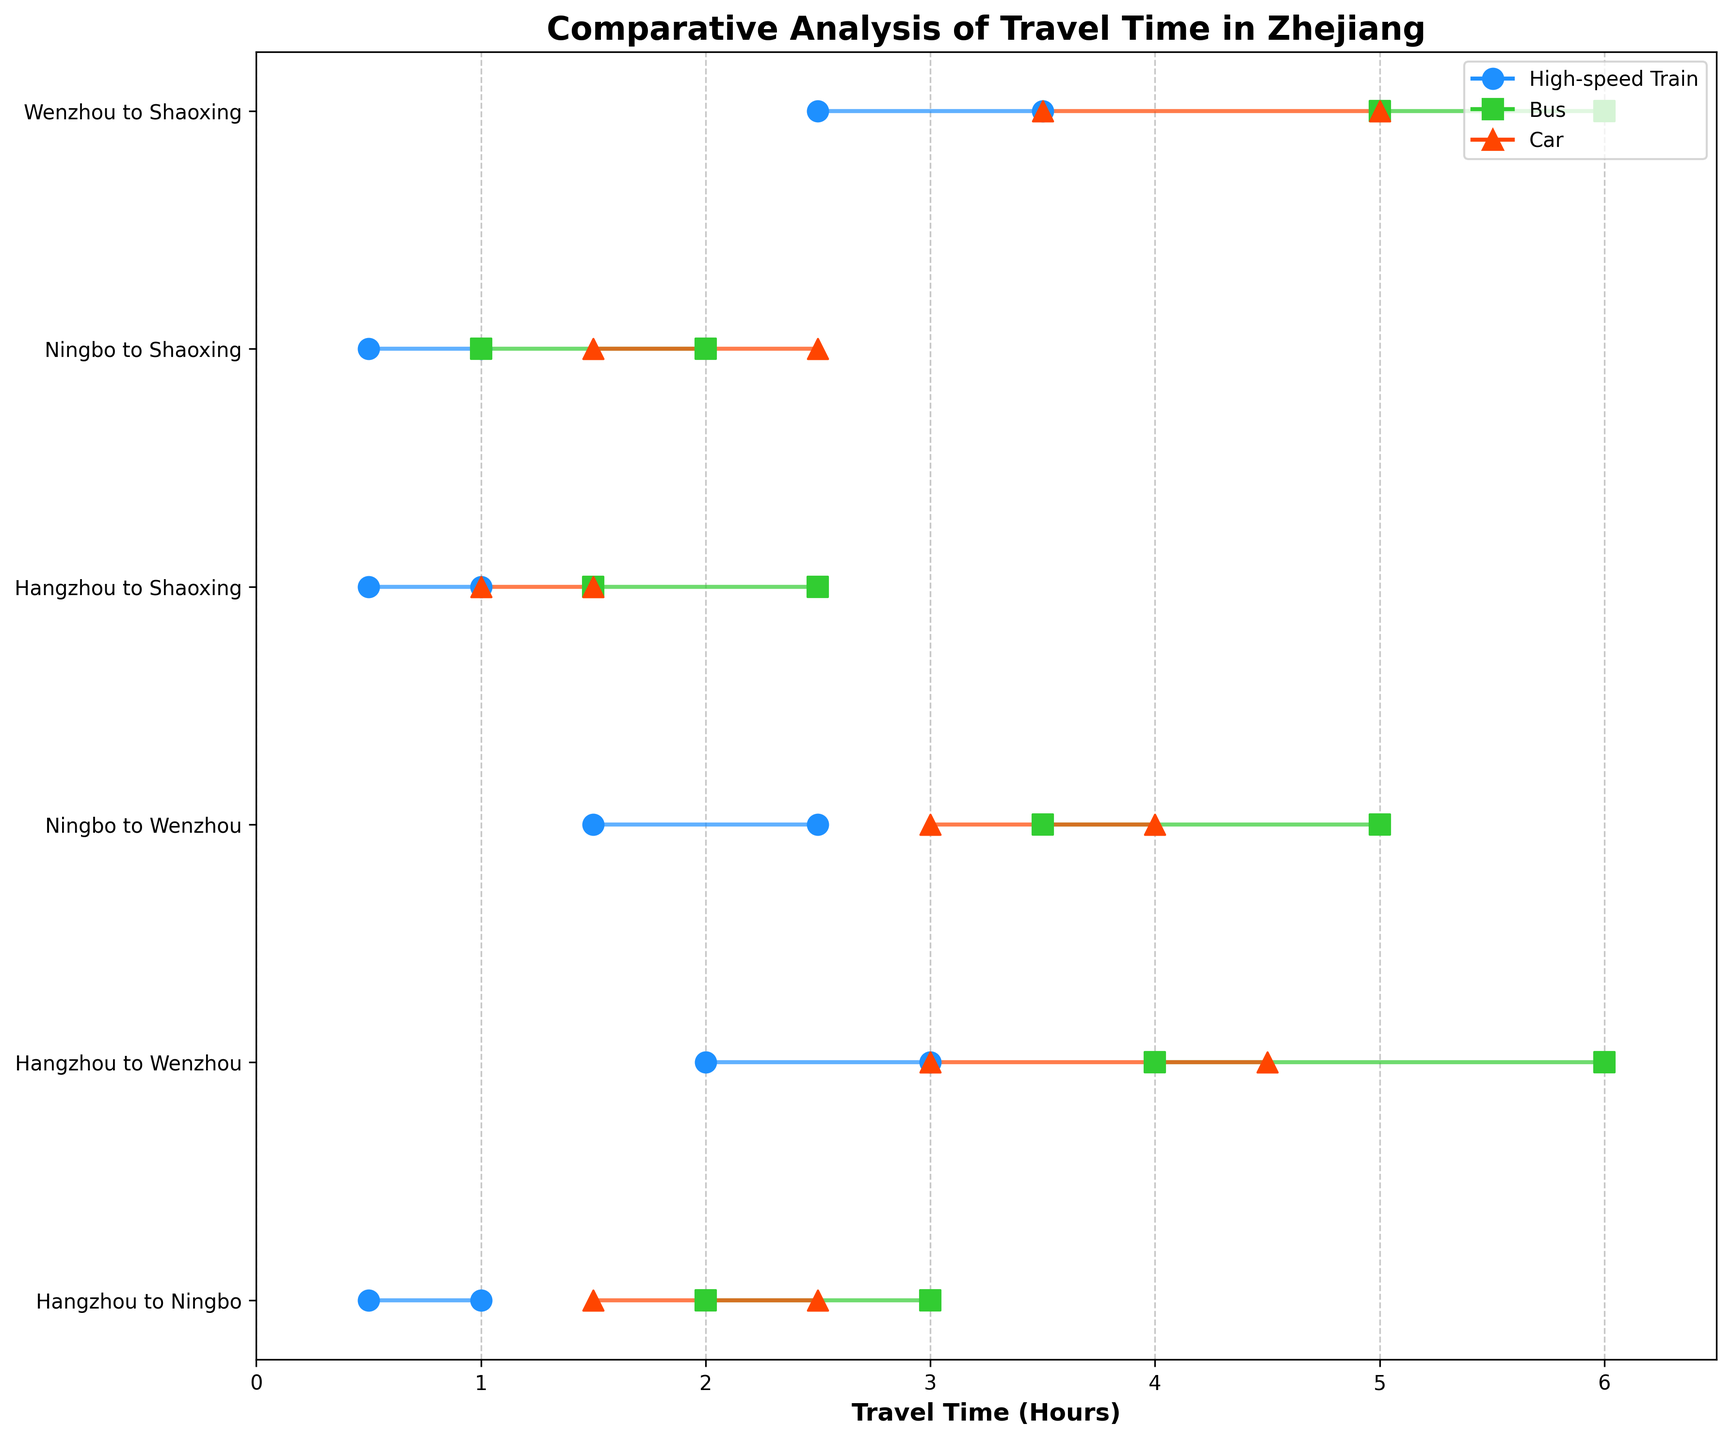Which transportation mode between Hangzhou and Ningbo has the shortest minimum travel time? Look at the 'Hangzhou to Ningbo' route and identify the minimum travel times for all modes. The shortest time is 0.5 hours by High-speed Train.
Answer: High-speed Train What is the maximum travel time for the Bus between Ningbo and Wenzhou? Locate the 'Ningbo to Wenzhou' route and check the maximum travel time for the Bus. It is 5 hours.
Answer: 5 hours Which route has the highest maximum travel time for a Car? Identify the highest maximum travel times across all routes and modes for Car. The 'Wenzhou to Shaoxing' route has the highest at 5 hours.
Answer: Wenzhou to Shaoxing Compare the range of travel times for the Car between Hangzhou and Shaoxing and the Car between Hangzhou and Ningbo. Which is shorter? Calculate the range (MaxTime - MinTime) for both routes. Hangzhou to Shaoxing: 1.5 - 1 = 0.5. Hangzhou to Ningbo: 2.5 - 1.5 = 1. The range for Hangzhou to Shaoxing is shorter.
Answer: Hangzhou to Shaoxing How many different routes are depicted in the chart? Count the unique combinations of origins and destinations in the data. There are 6 different routes.
Answer: 6 Which transportation mode shows the least variation in travel time for the route between Hangzhou and Wenzhou? For the 'Hangzhou to Wenzhou' route, calculate the range for each mode. High-speed Train: 3-2=1, Bus: 6-4=2, Car: 4.5-3=1. High-speed Train and Car show the least variation with a range of 1 hour.
Answer: High-speed Train, Car On average, between Ningbo and Shaoxing, what is the travel time range for all transportation modes combined? Calculate the ranges for each mode: High-speed Train: 1-0.5=0.5, Bus: 2-1=1, Car: 2.5-1.5=1. Average range: (0.5+1+1)/3 ≈ 0.83.
Answer: ≈ 0.83 Which route and mode combination has the longest minimum travel time? Scan through all minimum travel times in the data. The Bus from Wenzhou to Shaoxing has the longest minimum travel time at 5 hours.
Answer: Wenzhou to Shaoxing, Bus How does the range of travel times for the Bus between Hangzhou and Ningbo compare to the High-speed Train on the same route? Compare the ranges: High-speed Train: 1-0.5=0.5, Bus: 3-2=1. The Bus has a longer range of travel times.
Answer: Bus has a longer range What’s the difference in maximum travel time between the High-speed Train and Car from Ningbo to Wenzhou? Check the maximum travel time for each mode on the 'Ningbo to Wenzhou' route: High-speed Train: 2.5, Car: 4. Difference: 4-2.5 = 1.5 hours.
Answer: 1.5 hours 